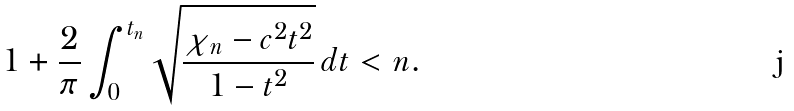Convert formula to latex. <formula><loc_0><loc_0><loc_500><loc_500>1 + \frac { 2 } { \pi } \int _ { 0 } ^ { t _ { n } } \sqrt { \frac { \chi _ { n } - c ^ { 2 } t ^ { 2 } } { 1 - t ^ { 2 } } } \, d t < n .</formula> 